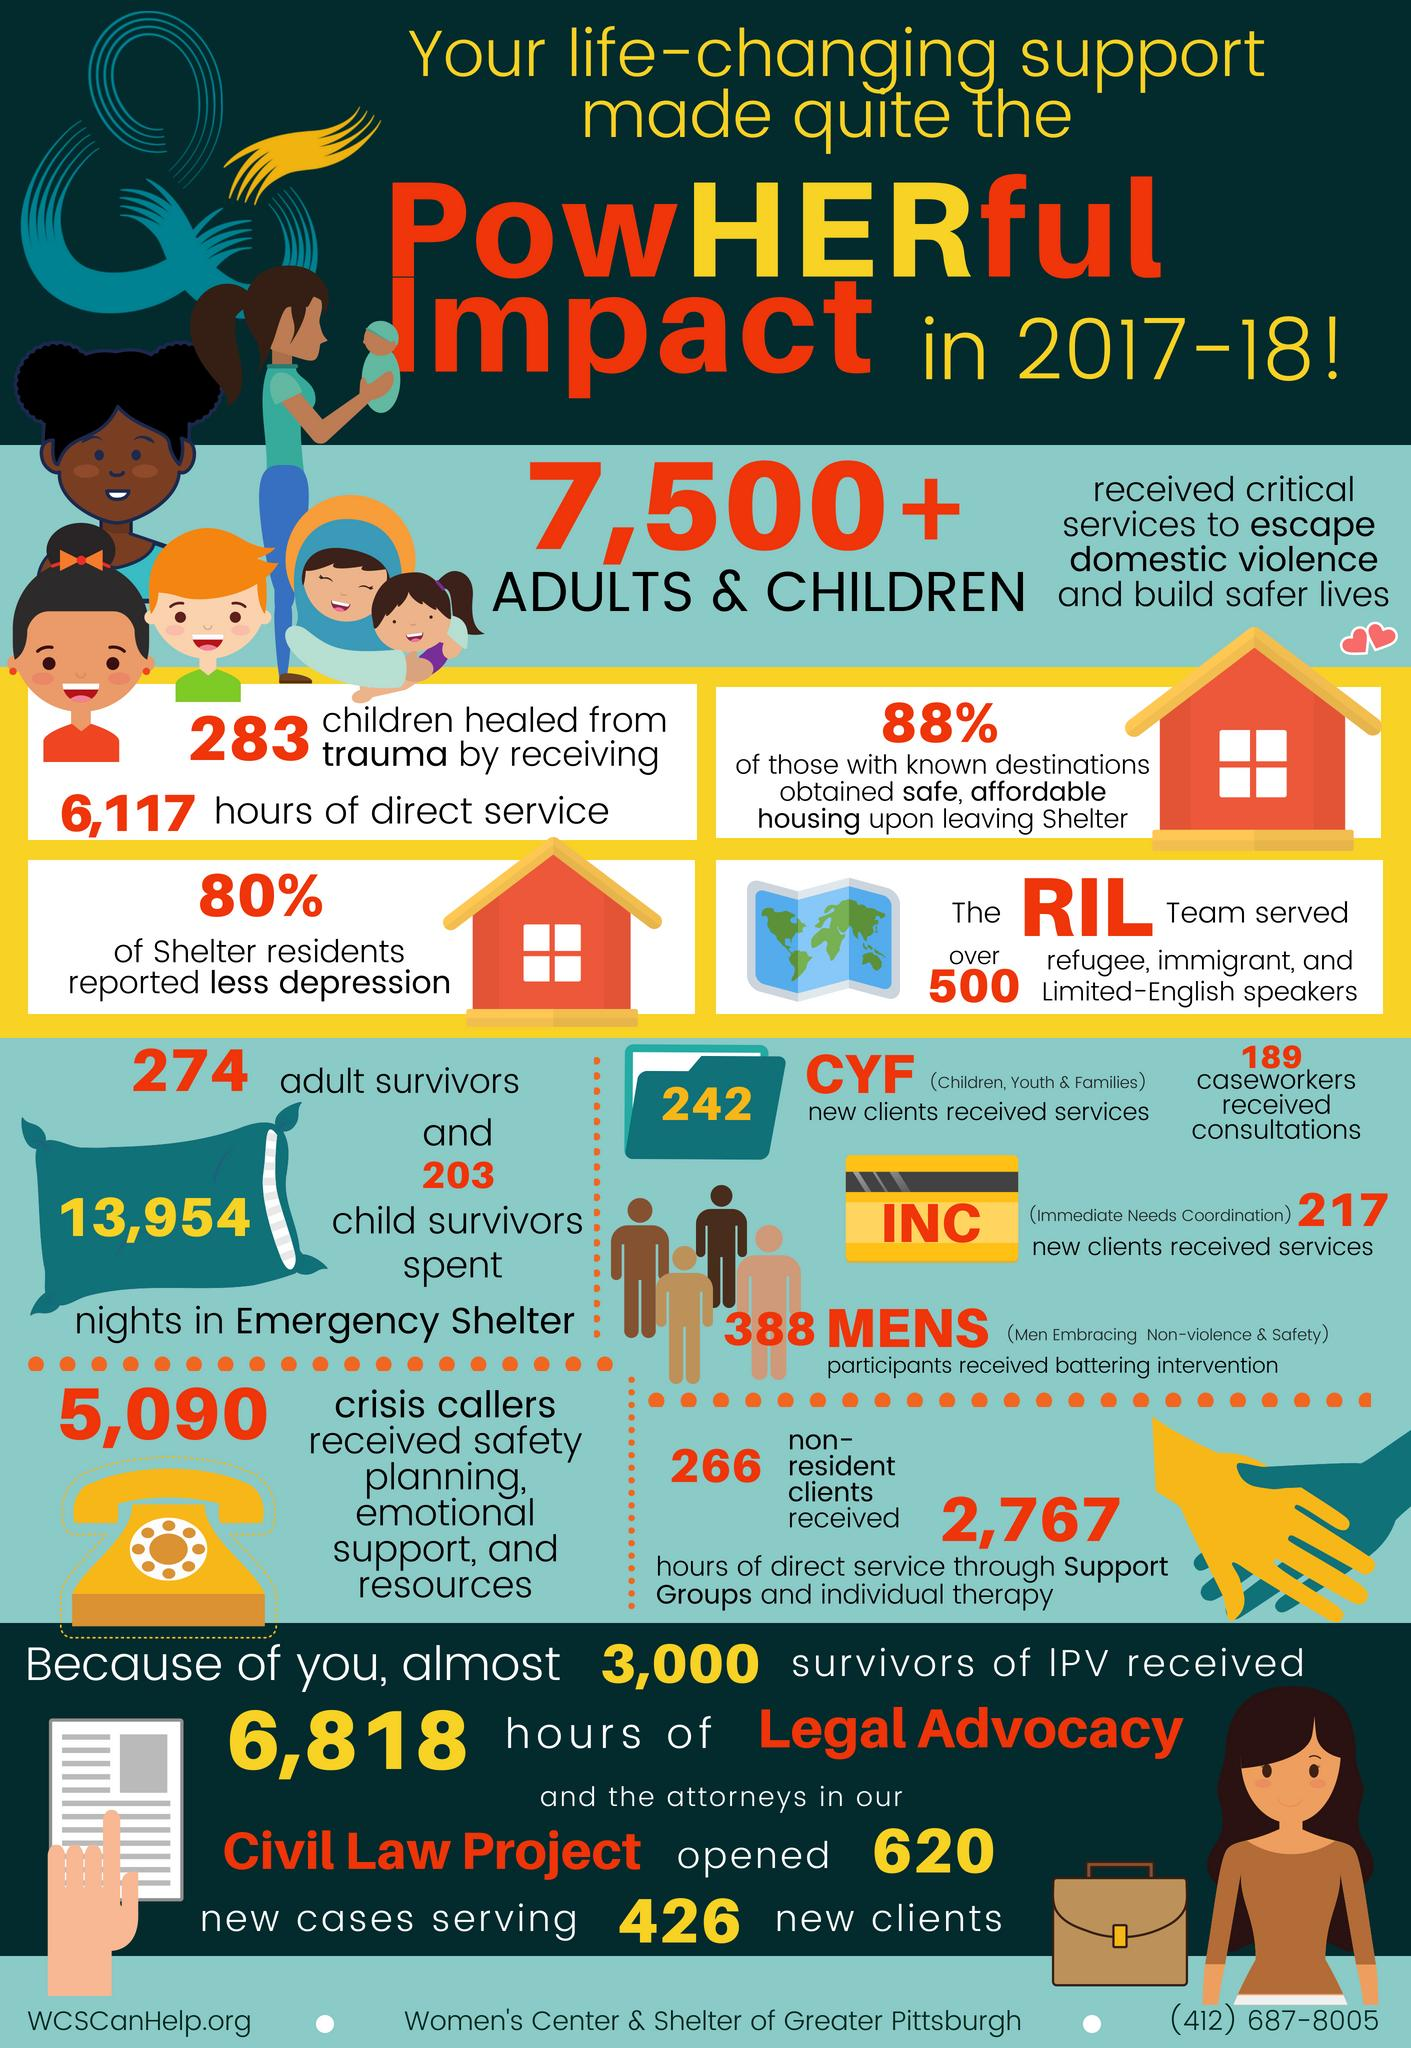Outline some significant characteristics in this image. The total number of new clients and non-resident clients received was 508. A total of 2,767 hours of service was provided through support groups, specifically 5090, 266, or 2767. During the crisis, a total of 13,954 nights were spent by both the adult and child survivors in shelters. 